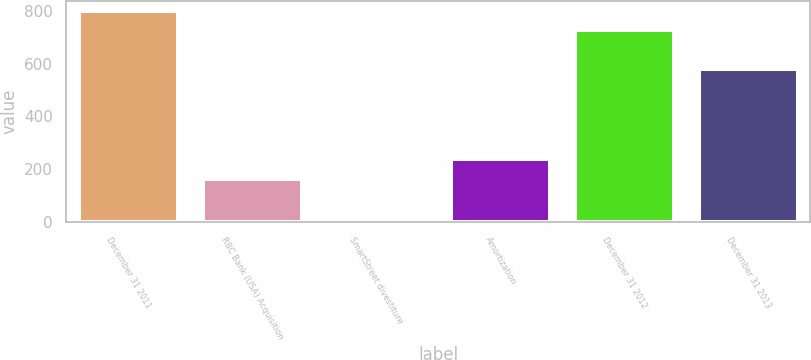Convert chart to OTSL. <chart><loc_0><loc_0><loc_500><loc_500><bar_chart><fcel>December 31 2011<fcel>RBC Bank (USA) Acquisition<fcel>SmartStreet divestiture<fcel>Amortization<fcel>December 31 2012<fcel>December 31 2013<nl><fcel>798.9<fcel>164<fcel>13<fcel>236.9<fcel>726<fcel>580<nl></chart> 